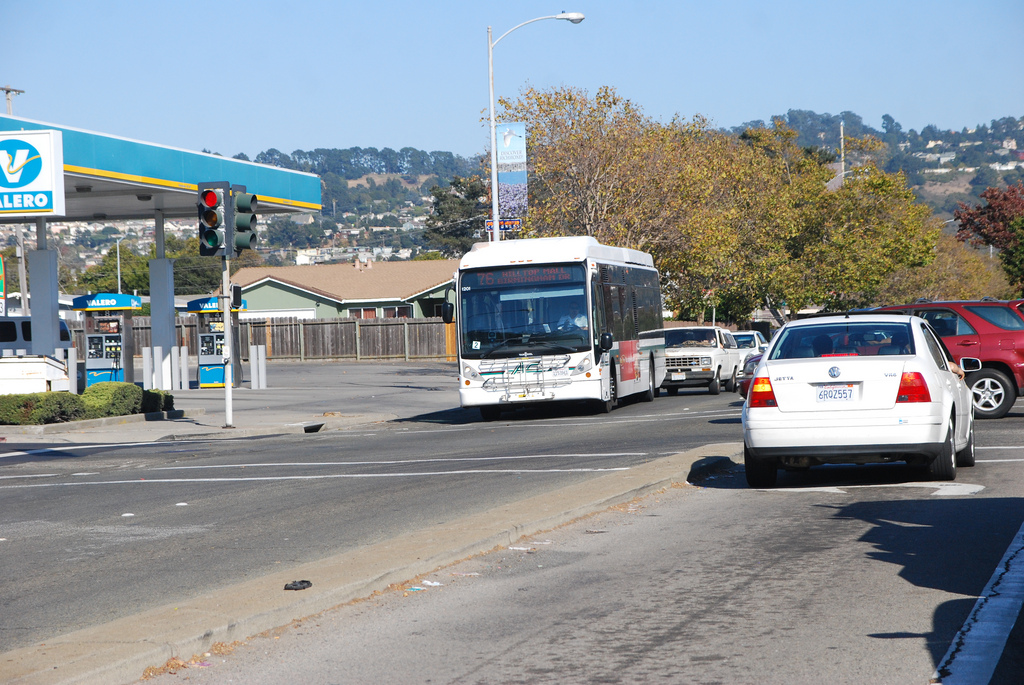On which side of the image is the car? The car is located on the right-hand side of the image, driving in the rightmost lane of the road. 